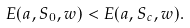Convert formula to latex. <formula><loc_0><loc_0><loc_500><loc_500>E ( { a } , { S } _ { 0 } , { w } ) < E ( { a } , { S } _ { c } , { w } ) .</formula> 